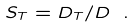<formula> <loc_0><loc_0><loc_500><loc_500>S _ { T } = D _ { T } / D \ .</formula> 